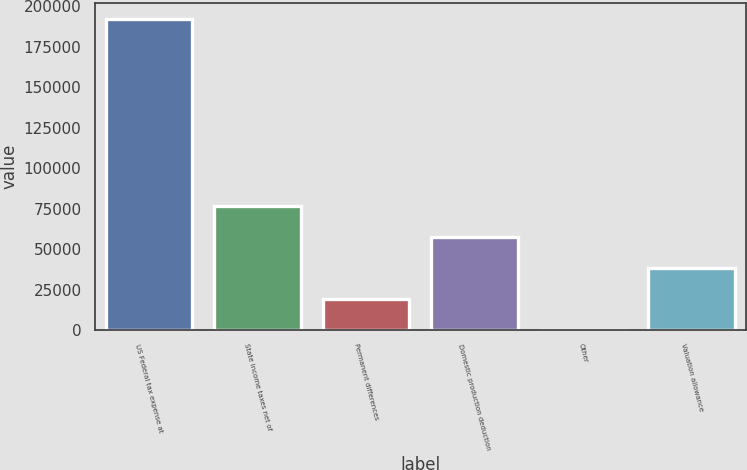<chart> <loc_0><loc_0><loc_500><loc_500><bar_chart><fcel>US Federal tax expense at<fcel>State income taxes net of<fcel>Permanent differences<fcel>Domestic production deduction<fcel>Other<fcel>Valuation allowance<nl><fcel>192204<fcel>76903.8<fcel>19253.7<fcel>57687.1<fcel>37<fcel>38470.4<nl></chart> 